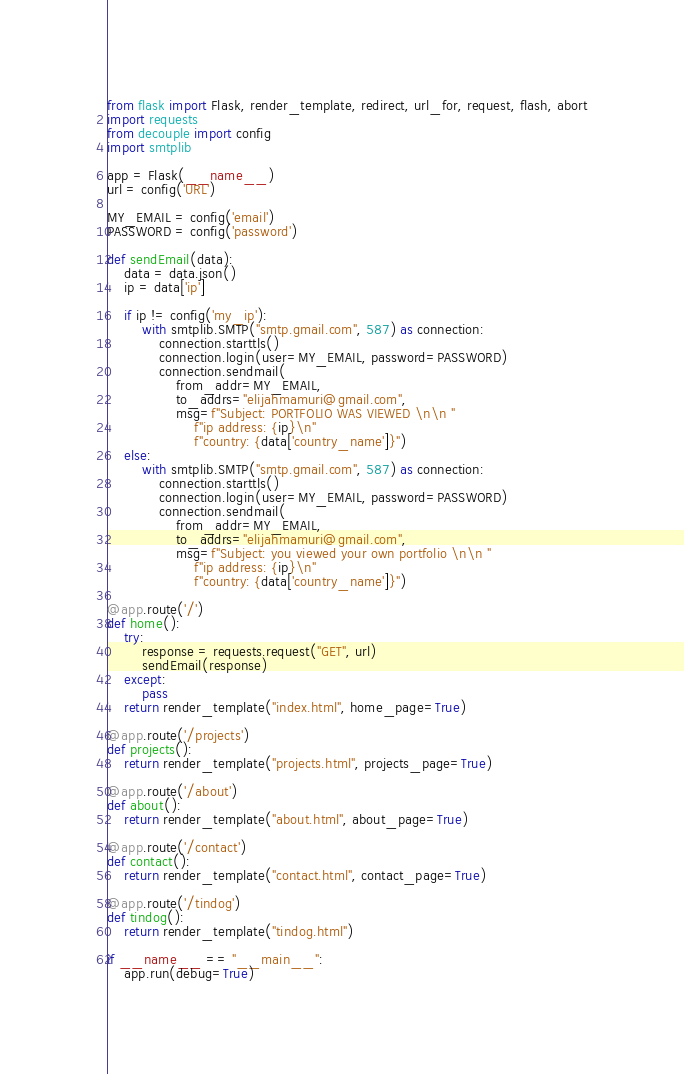Convert code to text. <code><loc_0><loc_0><loc_500><loc_500><_Python_>from flask import Flask, render_template, redirect, url_for, request, flash, abort
import requests
from decouple import config
import smtplib

app = Flask(__name__)
url = config('URL')

MY_EMAIL = config('email')
PASSWORD = config('password')

def sendEmail(data):
    data = data.json()
    ip = data['ip']

    if ip != config('my_ip'):
        with smtplib.SMTP("smtp.gmail.com", 587) as connection:
            connection.starttls()
            connection.login(user=MY_EMAIL, password=PASSWORD)
            connection.sendmail(
                from_addr=MY_EMAIL,
                to_addrs="elijahmamuri@gmail.com",
                msg=f"Subject: PORTFOLIO WAS VIEWED \n\n "
                    f"ip address: {ip}\n"
                    f"country: {data['country_name']}")
    else:
        with smtplib.SMTP("smtp.gmail.com", 587) as connection:
            connection.starttls()
            connection.login(user=MY_EMAIL, password=PASSWORD)
            connection.sendmail(
                from_addr=MY_EMAIL,
                to_addrs="elijahmamuri@gmail.com",
                msg=f"Subject: you viewed your own portfolio \n\n "
                    f"ip address: {ip}\n"
                    f"country: {data['country_name']}")

@app.route('/')
def home():
    try:
        response = requests.request("GET", url)
        sendEmail(response)
    except:
        pass
    return render_template("index.html", home_page=True)

@app.route('/projects')
def projects():
    return render_template("projects.html", projects_page=True)

@app.route('/about')
def about():
    return render_template("about.html", about_page=True)

@app.route('/contact')
def contact():
    return render_template("contact.html", contact_page=True)

@app.route('/tindog')
def tindog():
    return render_template("tindog.html")

if __name__ == "__main__":
    app.run(debug=True)</code> 